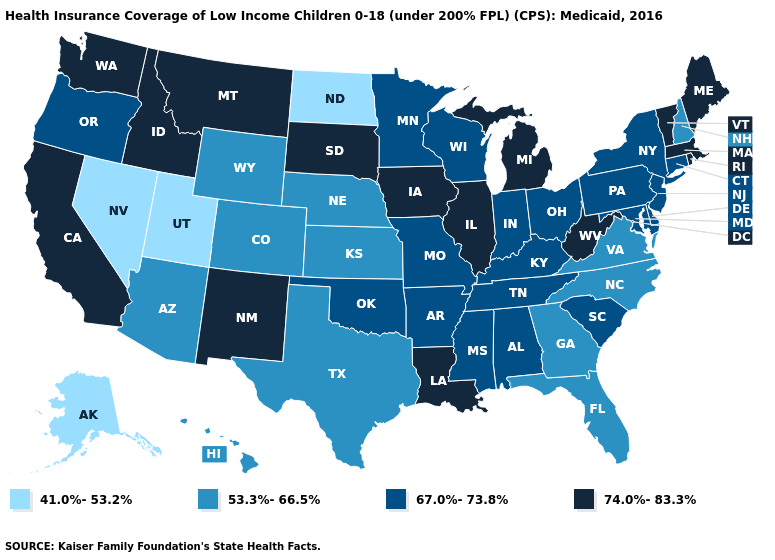Name the states that have a value in the range 41.0%-53.2%?
Answer briefly. Alaska, Nevada, North Dakota, Utah. Does the first symbol in the legend represent the smallest category?
Answer briefly. Yes. Does Mississippi have the same value as Kentucky?
Write a very short answer. Yes. Does Georgia have a lower value than Montana?
Give a very brief answer. Yes. Which states have the lowest value in the South?
Write a very short answer. Florida, Georgia, North Carolina, Texas, Virginia. What is the value of Florida?
Give a very brief answer. 53.3%-66.5%. Name the states that have a value in the range 53.3%-66.5%?
Concise answer only. Arizona, Colorado, Florida, Georgia, Hawaii, Kansas, Nebraska, New Hampshire, North Carolina, Texas, Virginia, Wyoming. Name the states that have a value in the range 67.0%-73.8%?
Be succinct. Alabama, Arkansas, Connecticut, Delaware, Indiana, Kentucky, Maryland, Minnesota, Mississippi, Missouri, New Jersey, New York, Ohio, Oklahoma, Oregon, Pennsylvania, South Carolina, Tennessee, Wisconsin. Name the states that have a value in the range 74.0%-83.3%?
Quick response, please. California, Idaho, Illinois, Iowa, Louisiana, Maine, Massachusetts, Michigan, Montana, New Mexico, Rhode Island, South Dakota, Vermont, Washington, West Virginia. Among the states that border Minnesota , which have the highest value?
Concise answer only. Iowa, South Dakota. What is the lowest value in states that border New Mexico?
Concise answer only. 41.0%-53.2%. What is the value of Hawaii?
Write a very short answer. 53.3%-66.5%. Does the first symbol in the legend represent the smallest category?
Concise answer only. Yes. What is the lowest value in the West?
Give a very brief answer. 41.0%-53.2%. Name the states that have a value in the range 74.0%-83.3%?
Keep it brief. California, Idaho, Illinois, Iowa, Louisiana, Maine, Massachusetts, Michigan, Montana, New Mexico, Rhode Island, South Dakota, Vermont, Washington, West Virginia. 